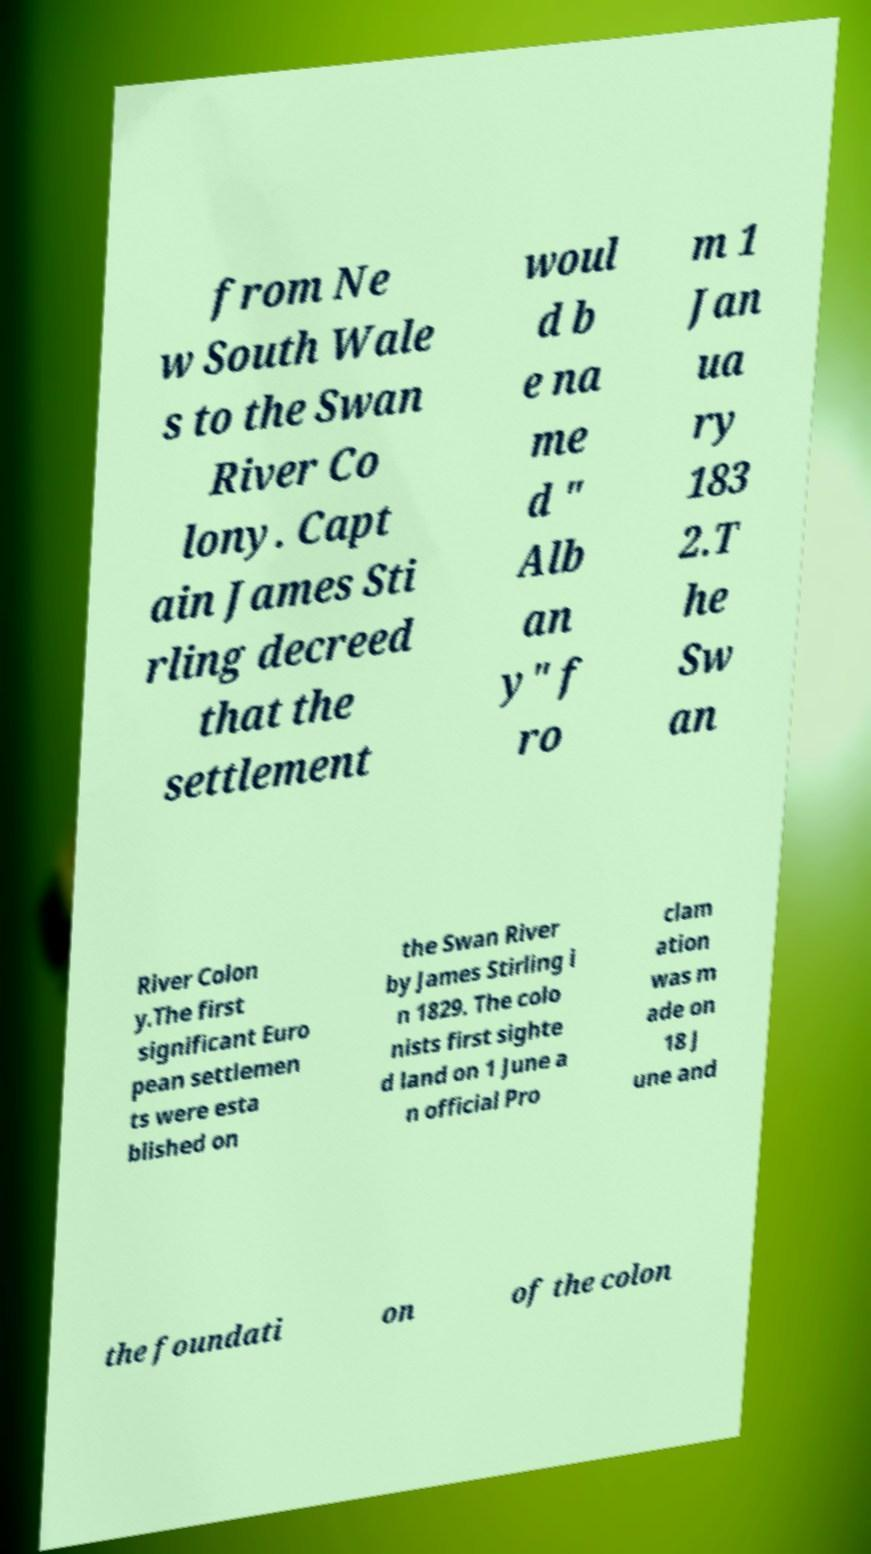For documentation purposes, I need the text within this image transcribed. Could you provide that? from Ne w South Wale s to the Swan River Co lony. Capt ain James Sti rling decreed that the settlement woul d b e na me d " Alb an y" f ro m 1 Jan ua ry 183 2.T he Sw an River Colon y.The first significant Euro pean settlemen ts were esta blished on the Swan River by James Stirling i n 1829. The colo nists first sighte d land on 1 June a n official Pro clam ation was m ade on 18 J une and the foundati on of the colon 